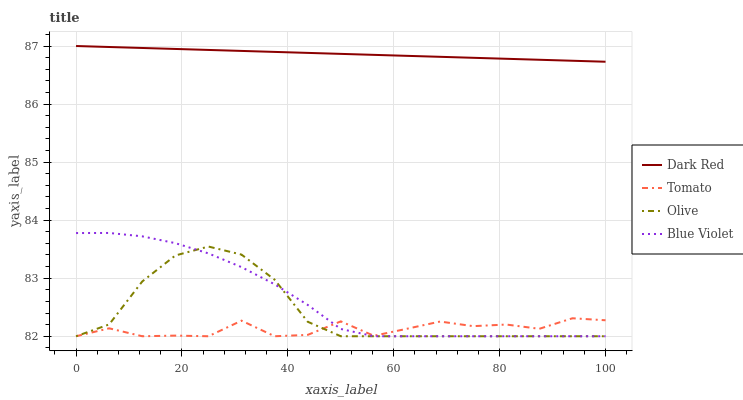Does Tomato have the minimum area under the curve?
Answer yes or no. Yes. Does Dark Red have the maximum area under the curve?
Answer yes or no. Yes. Does Blue Violet have the minimum area under the curve?
Answer yes or no. No. Does Blue Violet have the maximum area under the curve?
Answer yes or no. No. Is Dark Red the smoothest?
Answer yes or no. Yes. Is Tomato the roughest?
Answer yes or no. Yes. Is Blue Violet the smoothest?
Answer yes or no. No. Is Blue Violet the roughest?
Answer yes or no. No. Does Tomato have the lowest value?
Answer yes or no. Yes. Does Dark Red have the lowest value?
Answer yes or no. No. Does Dark Red have the highest value?
Answer yes or no. Yes. Does Blue Violet have the highest value?
Answer yes or no. No. Is Tomato less than Dark Red?
Answer yes or no. Yes. Is Dark Red greater than Olive?
Answer yes or no. Yes. Does Olive intersect Blue Violet?
Answer yes or no. Yes. Is Olive less than Blue Violet?
Answer yes or no. No. Is Olive greater than Blue Violet?
Answer yes or no. No. Does Tomato intersect Dark Red?
Answer yes or no. No. 